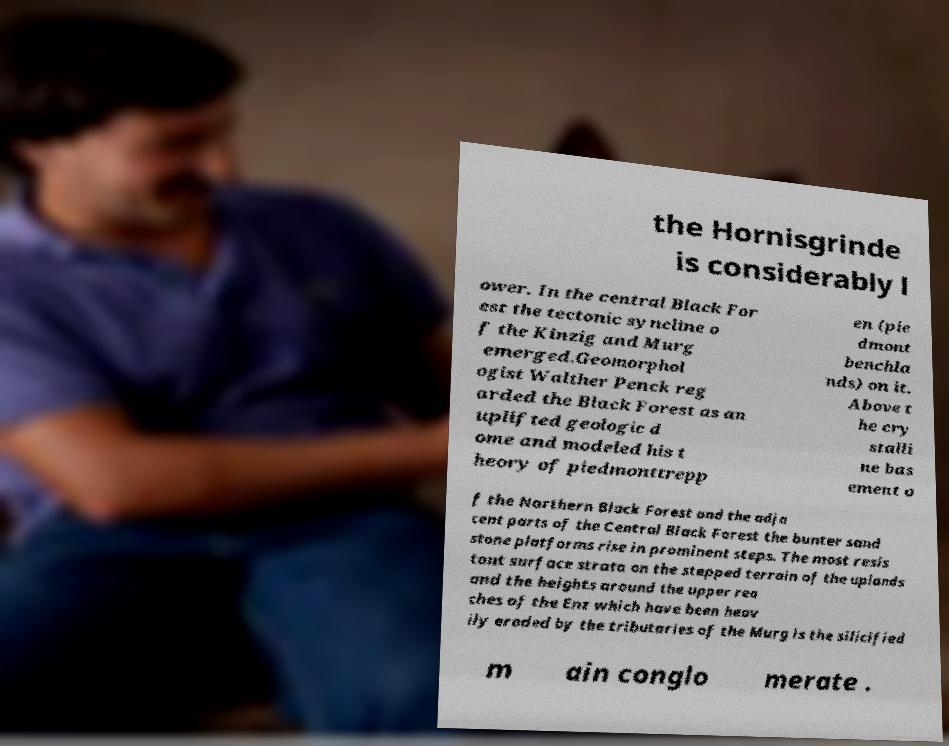Please read and relay the text visible in this image. What does it say? the Hornisgrinde is considerably l ower. In the central Black For est the tectonic syncline o f the Kinzig and Murg emerged.Geomorphol ogist Walther Penck reg arded the Black Forest as an uplifted geologic d ome and modeled his t heory of piedmonttrepp en (pie dmont benchla nds) on it. Above t he cry stalli ne bas ement o f the Northern Black Forest and the adja cent parts of the Central Black Forest the bunter sand stone platforms rise in prominent steps. The most resis tant surface strata on the stepped terrain of the uplands and the heights around the upper rea ches of the Enz which have been heav ily eroded by the tributaries of the Murg is the silicified m ain conglo merate . 